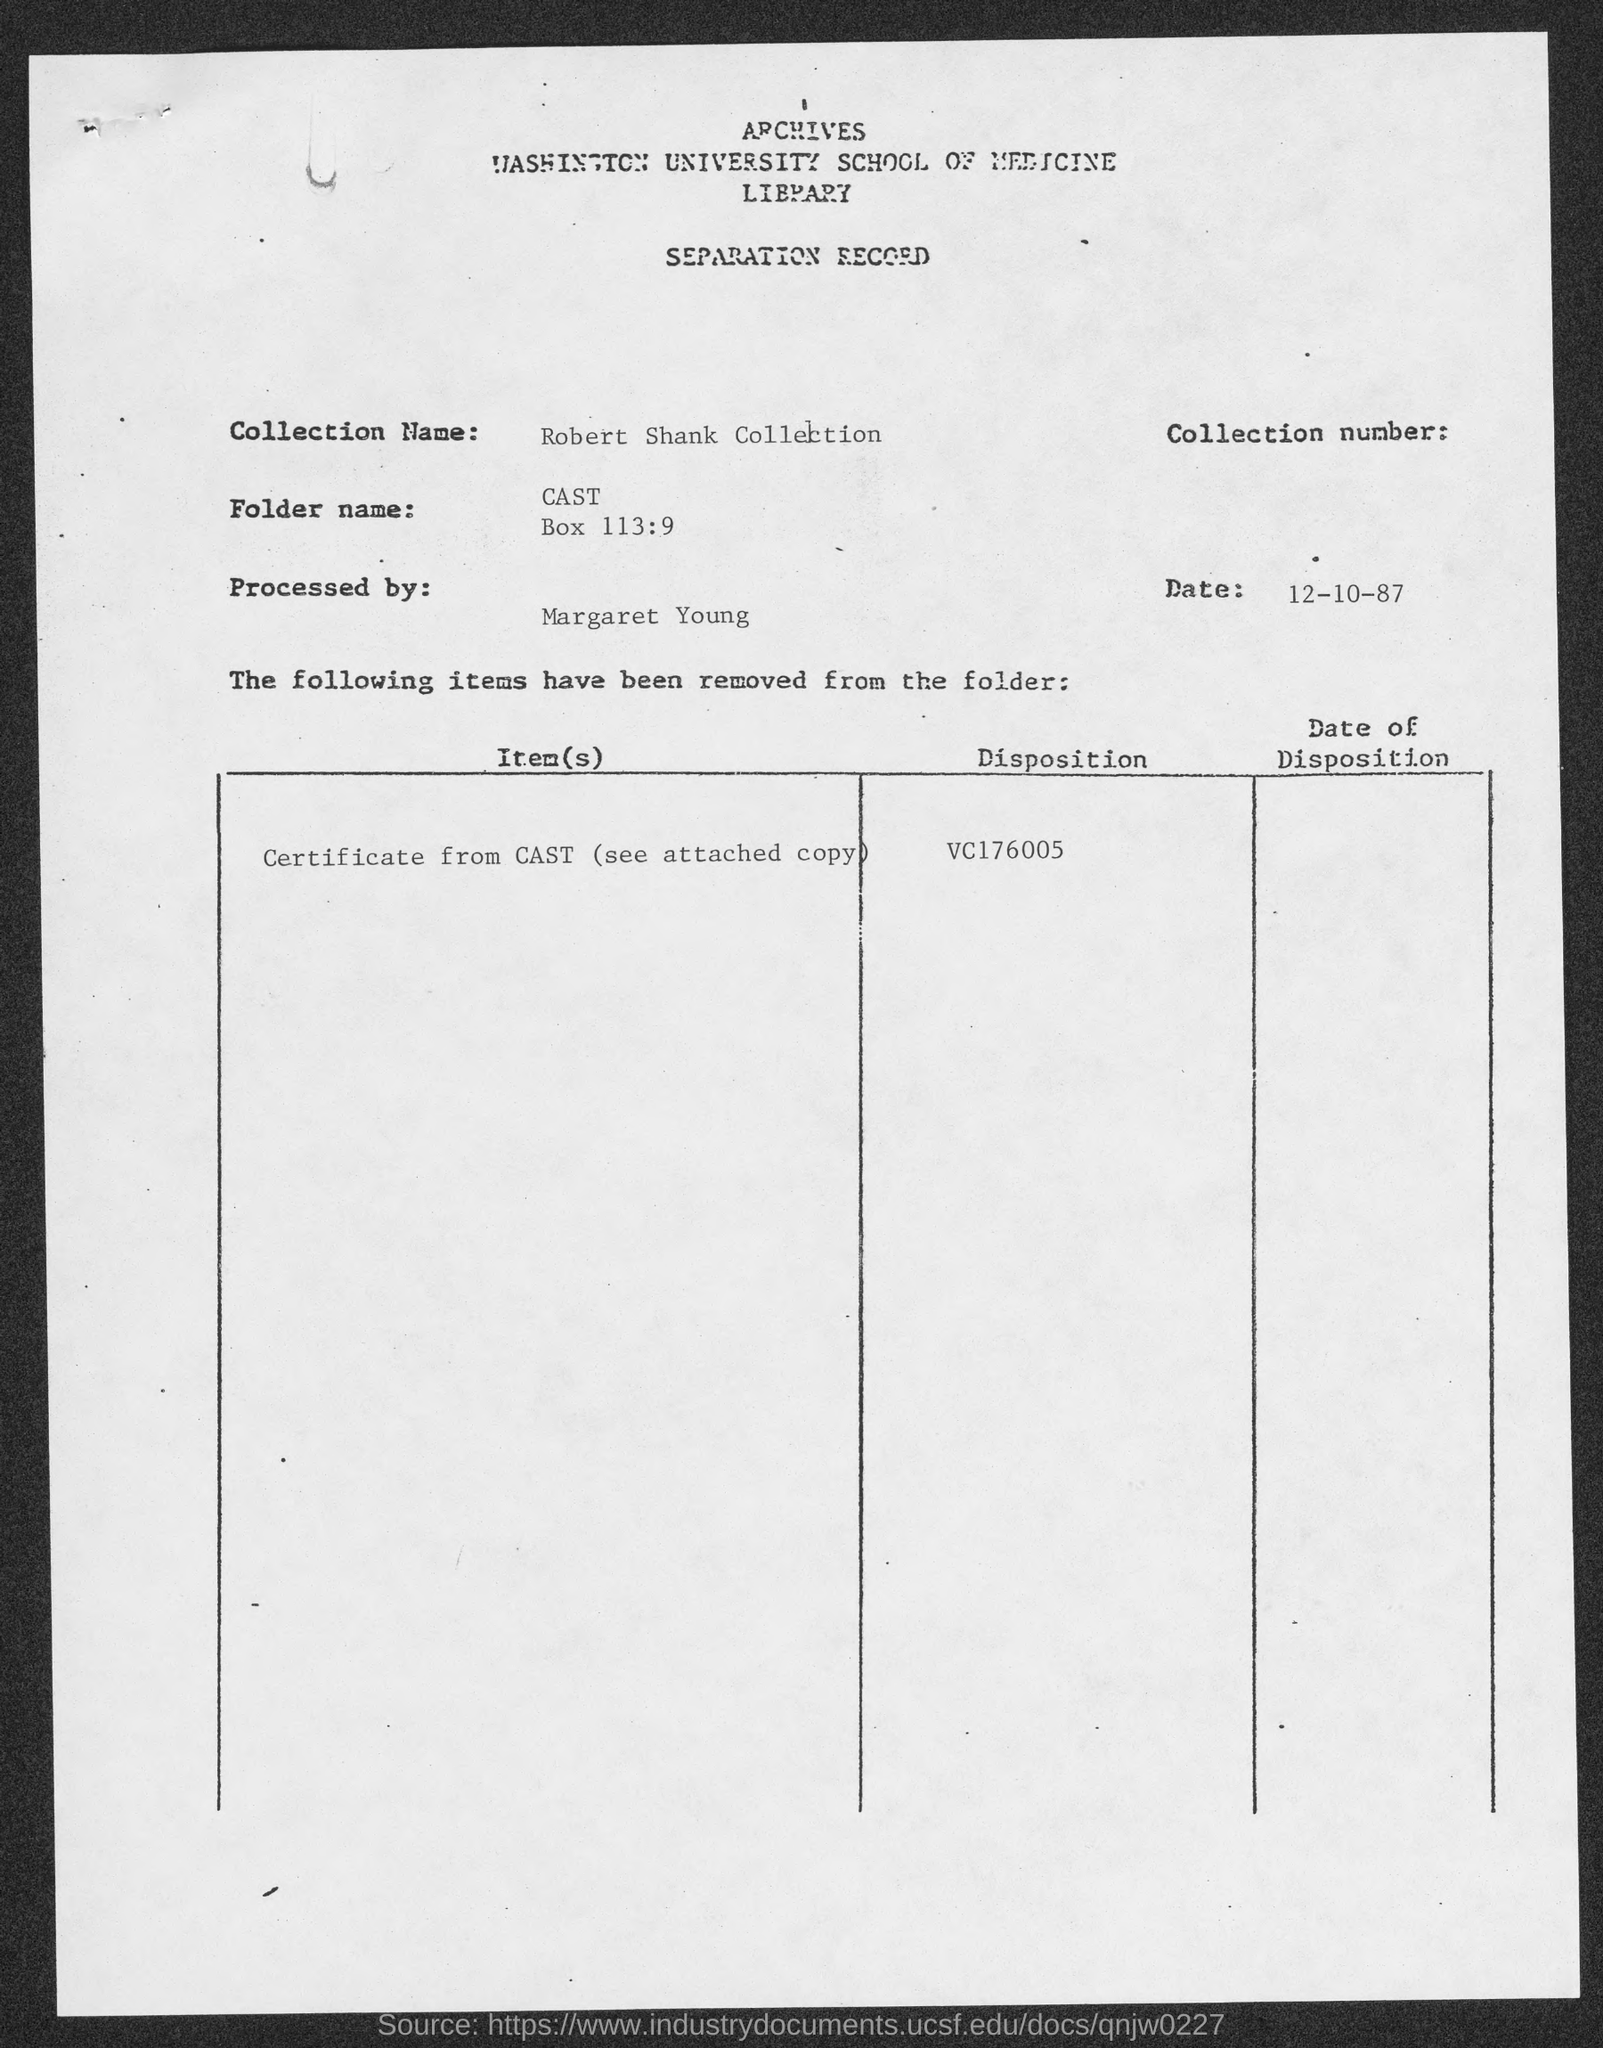What is the collection name given in the separation record?
Ensure brevity in your answer.  Robert Shank Collection. What is the date mentioned in the separation record?
Provide a short and direct response. 12-10-87. 